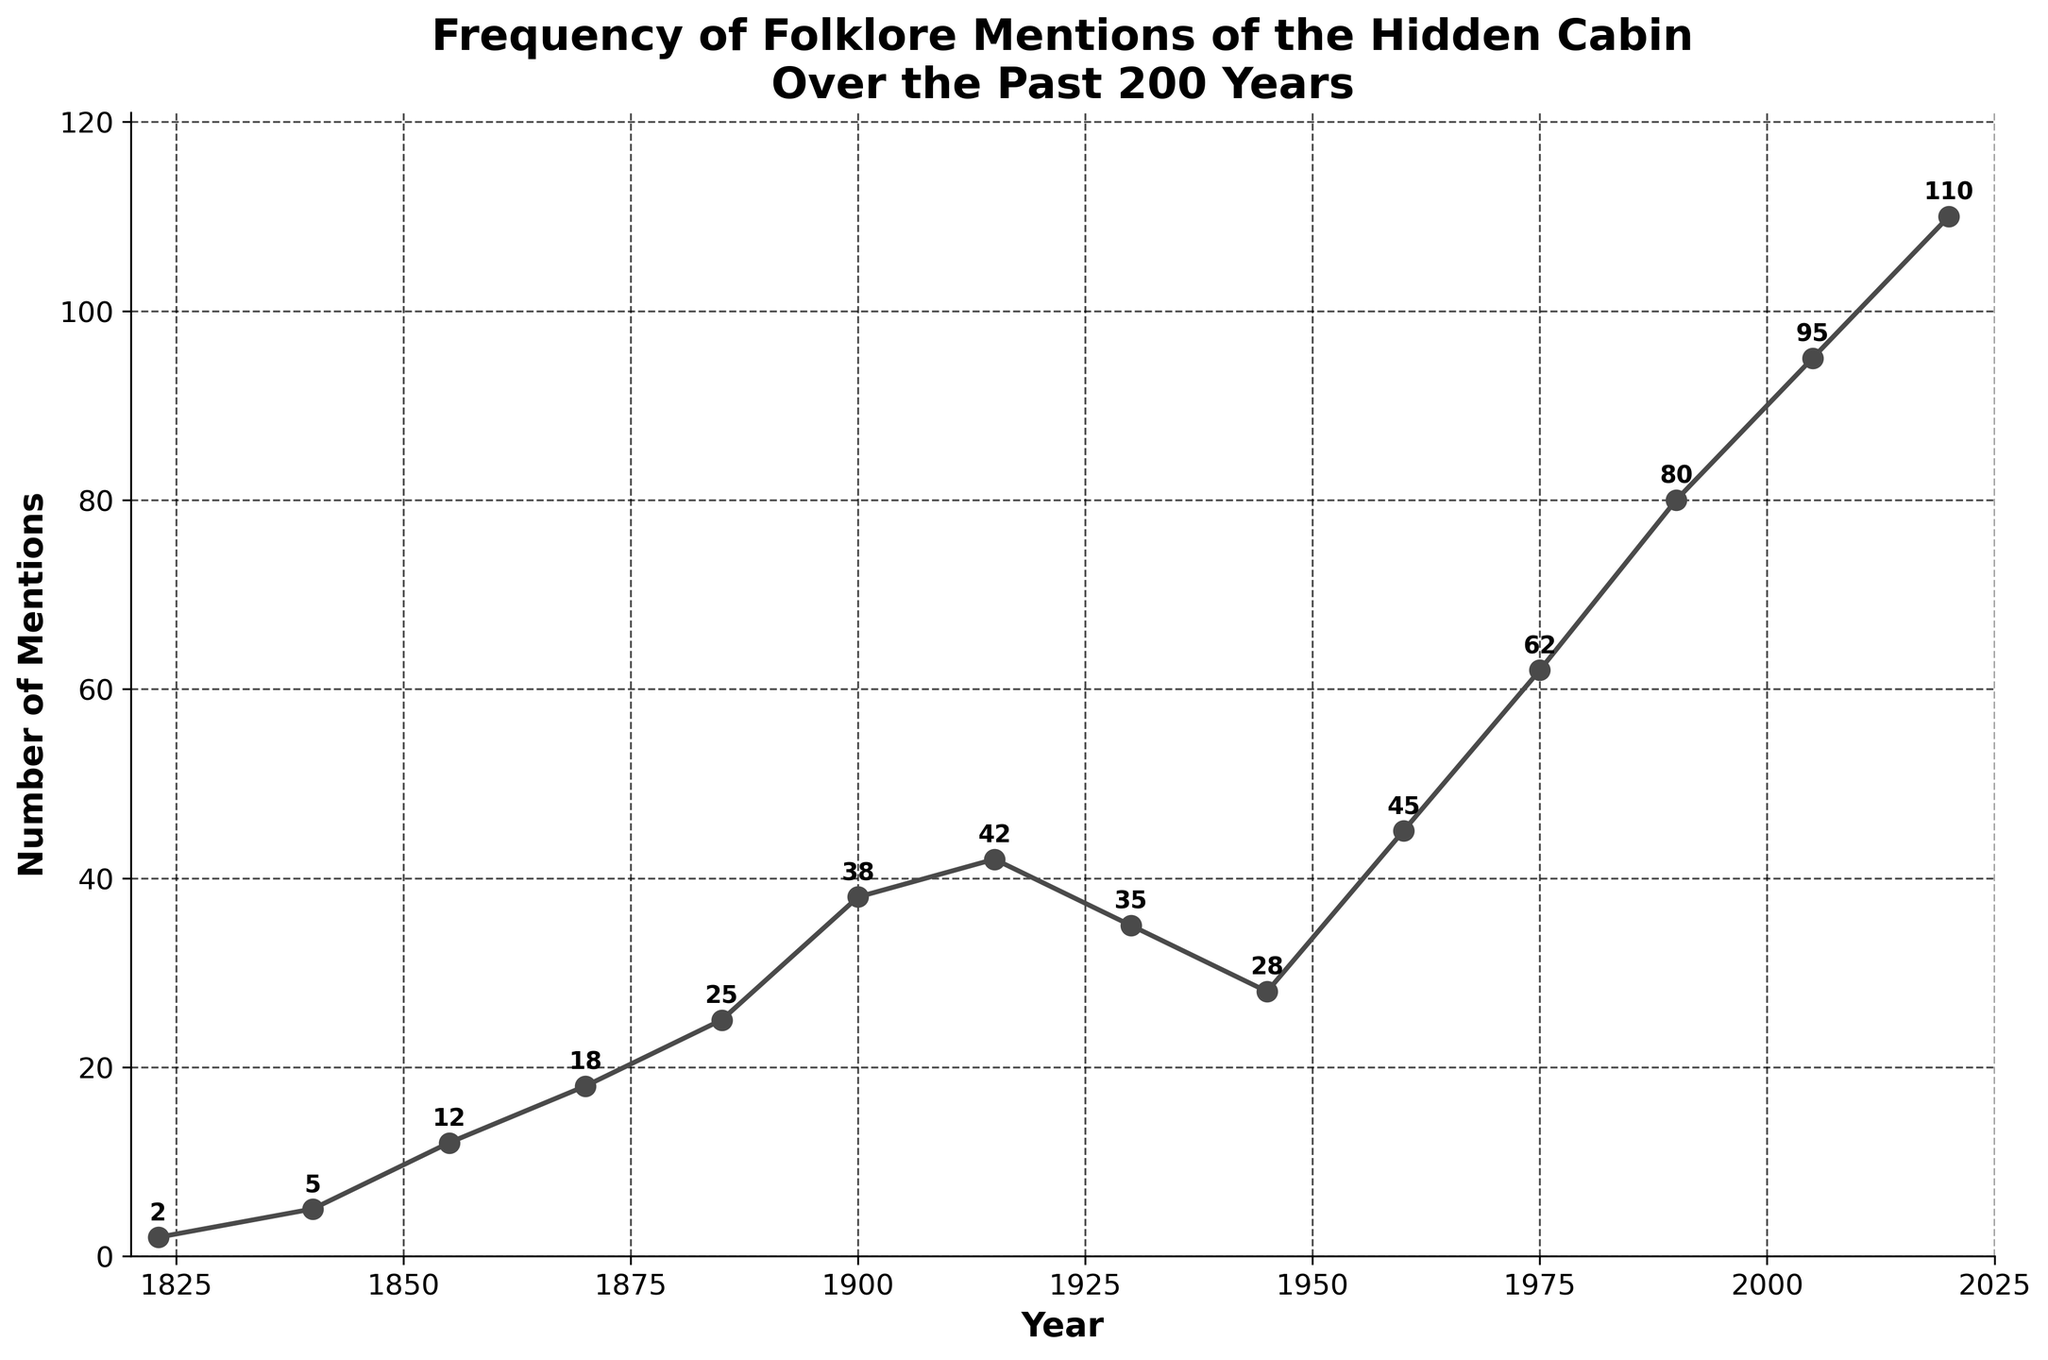What year saw the highest frequency of folklore mentions of the hidden cabin? The highest number of mentions is 110, which occurs in the year 2020.
Answer: 2020 Between 1960 and 1985, how much did the number of mentions increase by? In 1960, the mentions are 45, and in 1975, the mentions are 62. The increase from 45 to 62 is 62 - 45 = 17.
Answer: 17 Which two-year period experienced the steepest increase in mentions? From the data, the steepest increase is seen between 1985 (25 mentions) and 1900 (38 mentions), which is an increase of 38 - 25 = 13.
Answer: 1985 to 1900 How many times was the cabin mentioned in 1870 compared to 1823? In 1823, the mentions are 2, and in 1870, the mentions are 18. The ratio is 18 / 2 = 9 times.
Answer: 9 times What is the approximate average rate of increase in mentions per year between 1823 and 2020? The number of years between 1823 and 2020 is 2020 - 1823 = 197 years. The increase in mentions from 2 (1823) to 110 (2020) is 110 - 2 = 108. The average rate of increase per year is 108 / 197 ≈ 0.548.
Answer: 0.55 mentions per year Between which years does the plot show a decrease in the number of mentions? The data shows a decrease between 1915 and 1930 (42 to 35) and between 1930 and 1945 (35 to 28).
Answer: 1915 to 1930, 1930 to 1945 During which decade did the most rapid growth in mentions occur? From the data, the most rapid growth occurred between 1990 (80 mentions) and 2005 (95 mentions), which is an increase of 95 - 80 = 15 mentions in 15 years.
Answer: 1990 to 2005 How does the number of mentions in 1945 compare to 1823 and 2020? In 1823, there were 2 mentions, and in 2020, there were 110 mentions. In 1945, there were 28 mentions. Therefore, 1945 saw significantly more mentions than in 1823 (26 more) but significantly fewer than in 2020 (82 fewer).
Answer: More than 1823, fewer than 2020 What is the total number of mentions between 1855 and 1930? Adding the mentions between 1855 (12), 1870 (18), 1885 (25), 1900 (38), and 1930 (35), we get 12 + 18 + 25 + 38 + 35 = 128.
Answer: 128 How many mentions were there in the first 100 years (1823-1923), and in the second 100 years (1923-2020)? In the first 100 years: 1823 (2), 1840 (5), 1855 (12), 1870 (18), 1885 (25), 1900 (38), and 1915 (42). Sum: 2 + 5 + 12 + 18 + 25 + 38 + 42 = 142. In the second 100 years: 1930 (35), 1945 (28), 1960 (45), 1975 (62), 1990 (80), 2005 (95), and 2020 (110). Sum: 35 + 28 + 45 + 62 + 80 + 95 + 110 = 455.
Answer: First 100 years: 142, second 100 years: 455 